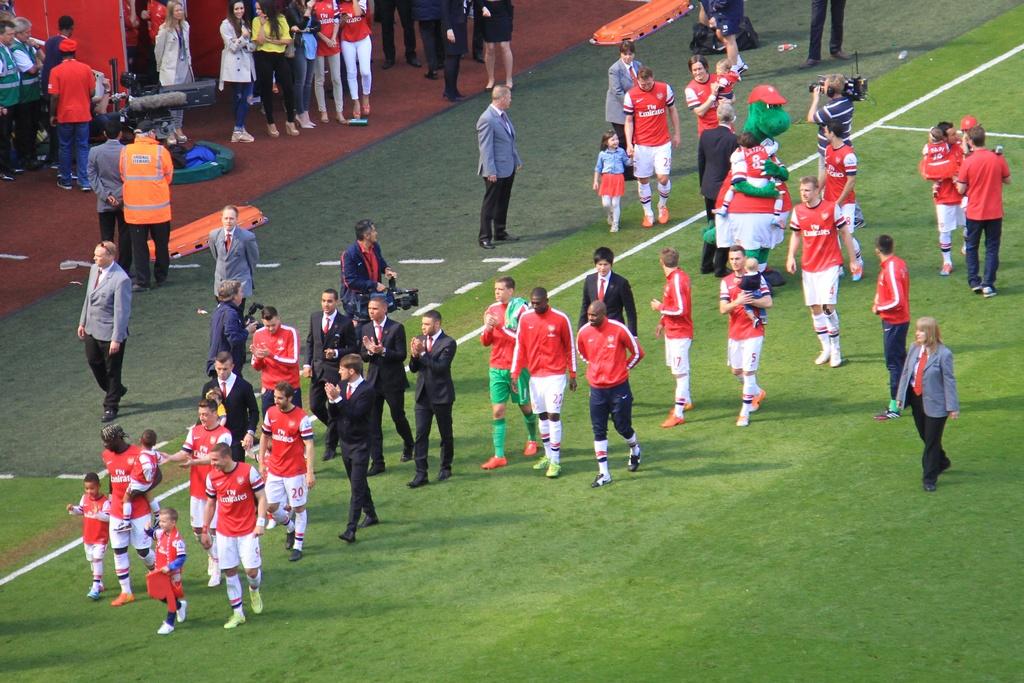What is one of the team member numbers?
Ensure brevity in your answer.  20. 